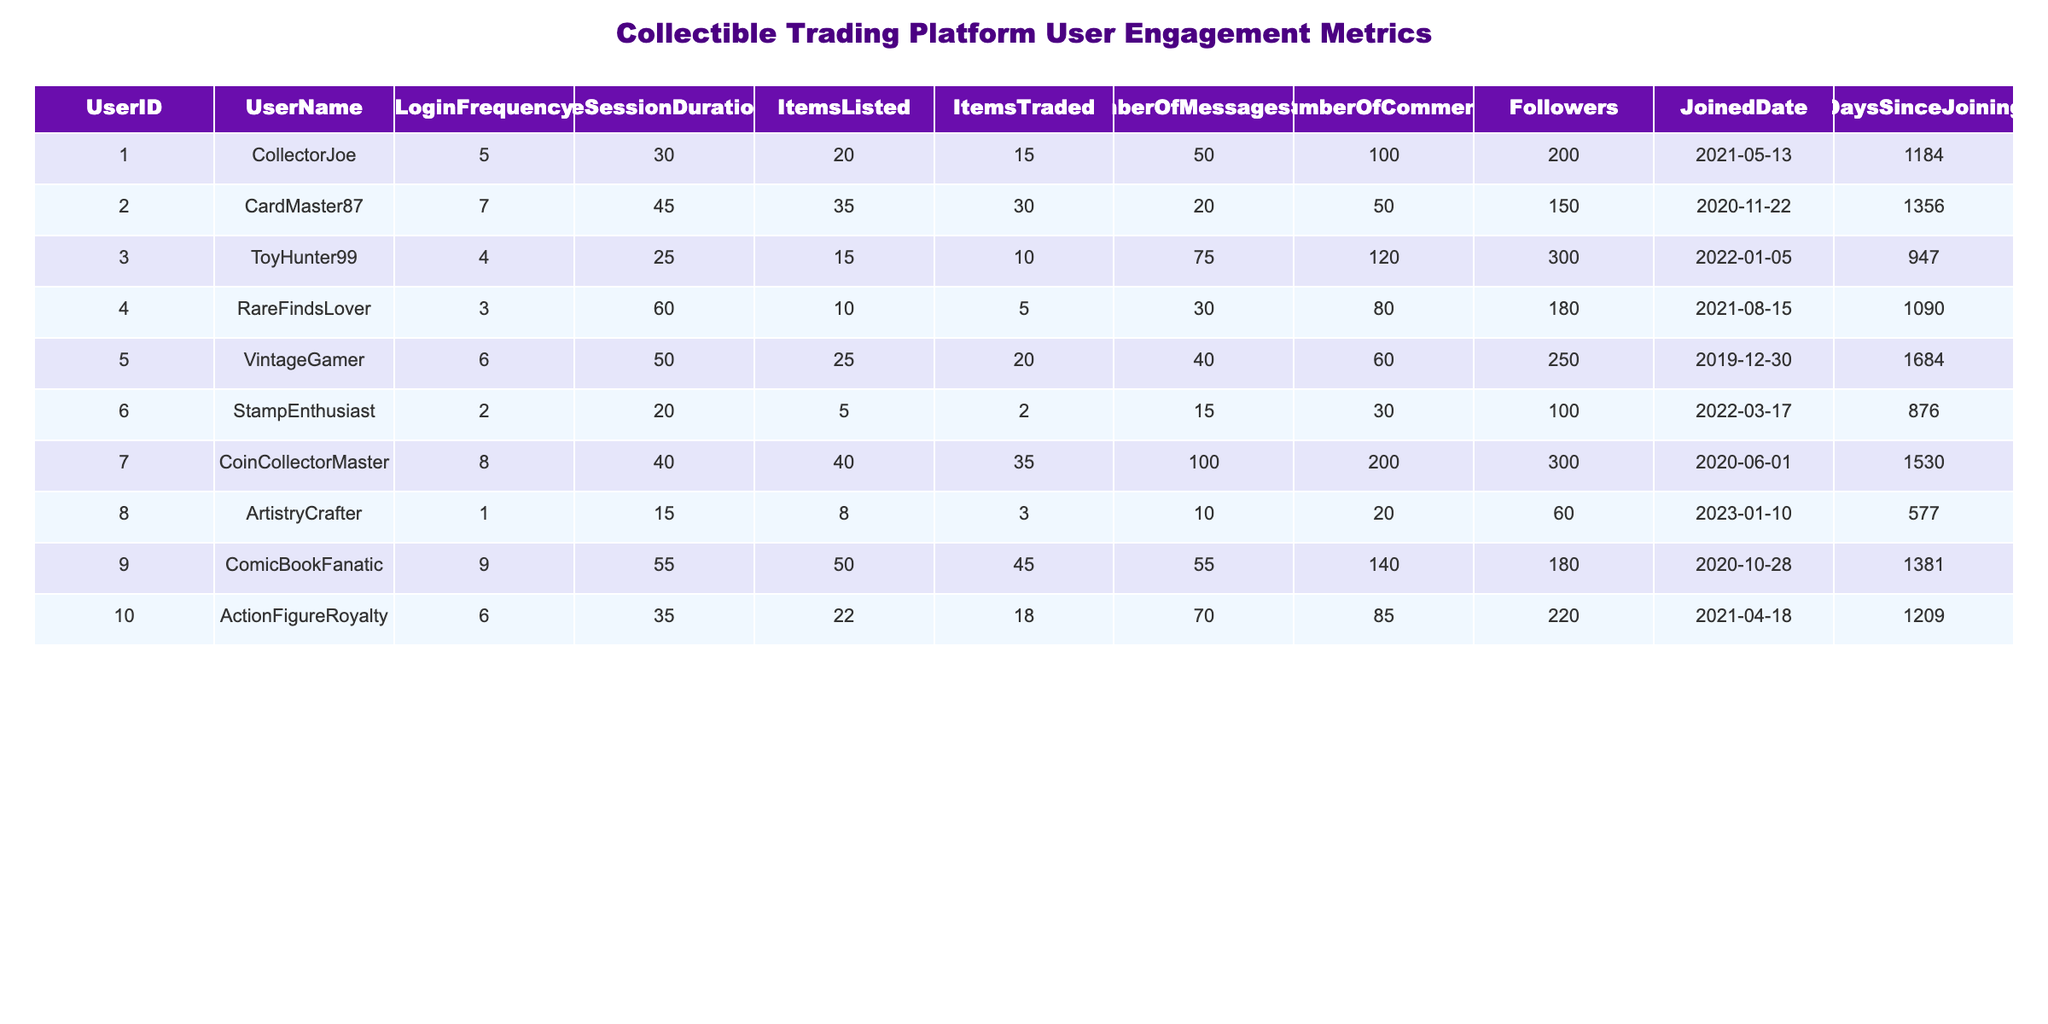What is the UserID of the user with the highest NumberOfMessagesSent? The table shows that CoinCollectorMaster, with UserID 7, has sent the highest number of messages, totaling 100.
Answer: 7 Which user joined the platform most recently? By comparing the JoinedDate column, ArtistryCrafter has the latest date of January 10, 2023, indicating they are the most recent user to join.
Answer: ArtistryCrafter What is the average AverageSessionDuration (in minutes) for all users in the table? To calculate the average, sum the AverageSessionDuration values (30 + 45 + 25 + 60 + 50 + 20 + 40 + 15 + 55 + 35 =  430) and divide by the number of users (10), giving 430/10 = 43 minutes.
Answer: 43 Is there any user who has never traded an item? By examining the ItemsTraded column, we see that StampEnthusiast (UserID 6) has traded 2 items, which means all users have traded at least one item.
Answer: No What is the difference between the maximum and minimum number of followers among the users? The maximum followers count is 300 (CoinCollectorMaster) and the minimum is 60 (ArtistryCrafter), thus the difference is 300 - 60 = 240.
Answer: 240 Which user has the highest ItemsListed and how many do they have? From the ItemsListed column, ComicBookFanatic has the highest number of listed items, totaling 50.
Answer: ComicBookFanatic, 50 What is the average number of ItemsTraded across all users? By summing the ItemsTraded values (15 + 30 + 10 + 5 + 20 + 2 + 35 + 3 + 45 + 18 =  188) and dividing by the number of users (10), the average is 188/10 = 18.8.
Answer: 18.8 Is the AverageSessionDuration of CollectorJoe more than 5 minutes? CollectorJoe's AverageSessionDuration is 30 minutes, which is indeed greater than 5 minutes, confirming that this claim is true.
Answer: Yes How many users have a LoginFrequency of 5 or more? By counting the LoginFrequency values that are 5 or more (CollectorJoe, CardMaster87, VintageGamer, CoinCollectorMaster, ComicBookFanatic, ActionFigureRoyalty), we find there are 6 such users.
Answer: 6 